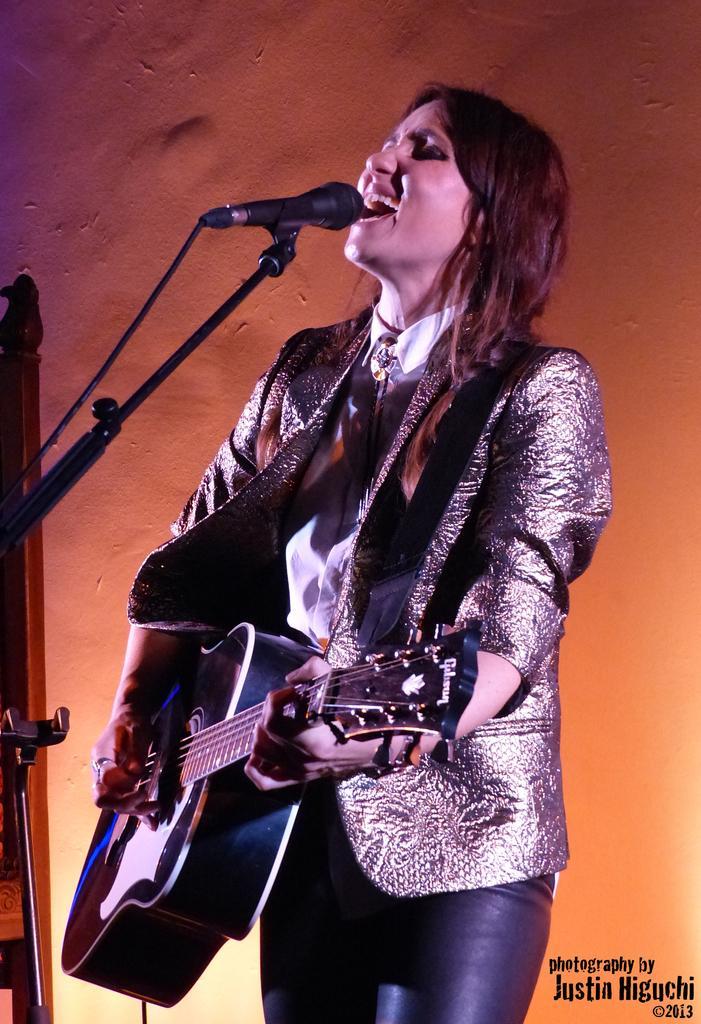Describe this image in one or two sentences. As we can see in the image there is a woman singing on mike and holding guitar in her hand. 